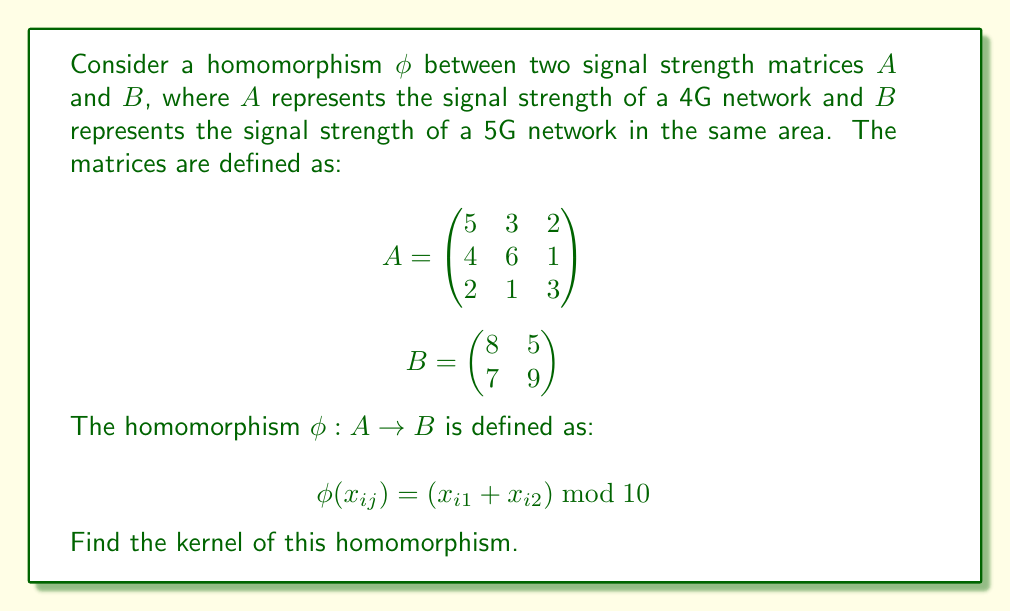Show me your answer to this math problem. To find the kernel of the homomorphism $\phi$, we need to determine all elements of matrix $A$ that map to the zero element in matrix $B$. Let's approach this step-by-step:

1) First, we need to understand what the zero element in $B$ would be. In this case, it's a $2 \times 2$ matrix with all elements equal to 0.

2) Now, we need to find all elements $x_{ij}$ in $A$ such that $\phi(x_{ij}) = 0$. This means:

   $(x_{i1} + x_{i2}) \bmod 10 = 0$

3) Let's examine each row of $A$:

   Row 1: $(5 + 3) \bmod 10 = 8 \neq 0$
   Row 2: $(4 + 6) \bmod 10 = 0$
   Row 3: $(2 + 1) \bmod 10 = 3 \neq 0$

4) We see that only the second row of $A$ maps to 0 under $\phi$.

5) Therefore, the kernel of $\phi$ consists of all matrices of the form:

   $\begin{pmatrix}
   0 & 0 & 0 \\
   a & b & c \\
   0 & 0 & 0
   \end{pmatrix}$

   where $a + b \equiv 0 \pmod{10}$, and $c$ can be any integer.

6) We can represent this more compactly as:

   $\text{ker}(\phi) = \left\{\begin{pmatrix}
   0 & 0 & 0 \\
   a & (10-a) \bmod 10 & c \\
   0 & 0 & 0
   \end{pmatrix} : a, c \in \mathbb{Z}\right\}$

This set represents all signal strength configurations in the 4G network that would not affect the corresponding 5G network under this specific transformation.
Answer: $\text{ker}(\phi) = \left\{\begin{pmatrix}
0 & 0 & 0 \\
a & (10-a) \bmod 10 & c \\
0 & 0 & 0
\end{pmatrix} : a, c \in \mathbb{Z}\right\}$ 